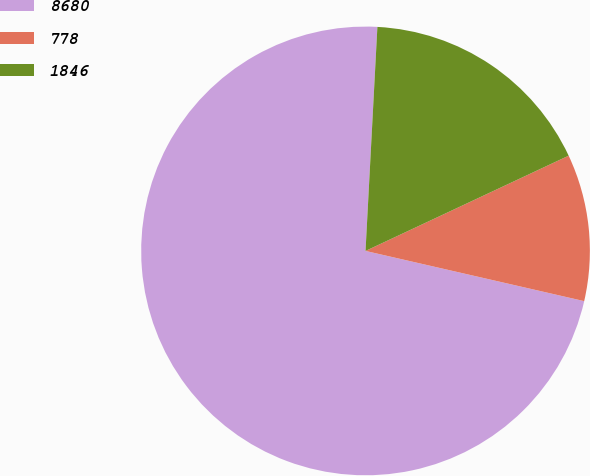Convert chart to OTSL. <chart><loc_0><loc_0><loc_500><loc_500><pie_chart><fcel>8680<fcel>778<fcel>1846<nl><fcel>72.25%<fcel>10.57%<fcel>17.18%<nl></chart> 